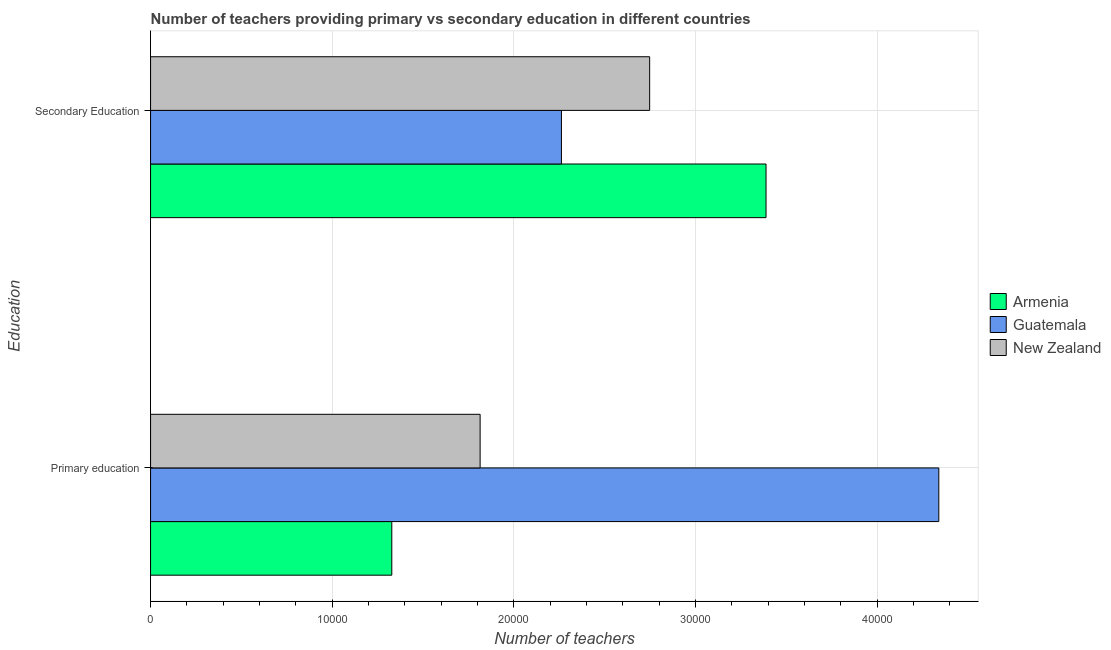How many different coloured bars are there?
Provide a succinct answer. 3. How many groups of bars are there?
Ensure brevity in your answer.  2. Are the number of bars per tick equal to the number of legend labels?
Your response must be concise. Yes. Are the number of bars on each tick of the Y-axis equal?
Provide a succinct answer. Yes. What is the number of secondary teachers in Guatemala?
Ensure brevity in your answer.  2.26e+04. Across all countries, what is the maximum number of secondary teachers?
Your answer should be very brief. 3.39e+04. Across all countries, what is the minimum number of primary teachers?
Offer a terse response. 1.33e+04. In which country was the number of secondary teachers maximum?
Offer a terse response. Armenia. In which country was the number of primary teachers minimum?
Offer a terse response. Armenia. What is the total number of secondary teachers in the graph?
Offer a very short reply. 8.40e+04. What is the difference between the number of primary teachers in New Zealand and that in Armenia?
Keep it short and to the point. 4863. What is the difference between the number of primary teachers in Armenia and the number of secondary teachers in New Zealand?
Your response must be concise. -1.42e+04. What is the average number of primary teachers per country?
Ensure brevity in your answer.  2.49e+04. What is the difference between the number of primary teachers and number of secondary teachers in Armenia?
Give a very brief answer. -2.06e+04. What is the ratio of the number of primary teachers in Guatemala to that in Armenia?
Offer a very short reply. 3.27. In how many countries, is the number of primary teachers greater than the average number of primary teachers taken over all countries?
Provide a succinct answer. 1. What does the 2nd bar from the top in Secondary Education represents?
Keep it short and to the point. Guatemala. What does the 2nd bar from the bottom in Secondary Education represents?
Make the answer very short. Guatemala. Are all the bars in the graph horizontal?
Make the answer very short. Yes. Are the values on the major ticks of X-axis written in scientific E-notation?
Ensure brevity in your answer.  No. Does the graph contain any zero values?
Offer a very short reply. No. Does the graph contain grids?
Your answer should be very brief. Yes. How are the legend labels stacked?
Your answer should be compact. Vertical. What is the title of the graph?
Offer a very short reply. Number of teachers providing primary vs secondary education in different countries. Does "Cayman Islands" appear as one of the legend labels in the graph?
Your answer should be very brief. No. What is the label or title of the X-axis?
Provide a succinct answer. Number of teachers. What is the label or title of the Y-axis?
Keep it short and to the point. Education. What is the Number of teachers in Armenia in Primary education?
Your response must be concise. 1.33e+04. What is the Number of teachers in Guatemala in Primary education?
Provide a short and direct response. 4.34e+04. What is the Number of teachers of New Zealand in Primary education?
Your answer should be compact. 1.81e+04. What is the Number of teachers of Armenia in Secondary Education?
Offer a terse response. 3.39e+04. What is the Number of teachers in Guatemala in Secondary Education?
Your answer should be compact. 2.26e+04. What is the Number of teachers in New Zealand in Secondary Education?
Your response must be concise. 2.75e+04. Across all Education, what is the maximum Number of teachers in Armenia?
Your response must be concise. 3.39e+04. Across all Education, what is the maximum Number of teachers in Guatemala?
Offer a very short reply. 4.34e+04. Across all Education, what is the maximum Number of teachers in New Zealand?
Make the answer very short. 2.75e+04. Across all Education, what is the minimum Number of teachers in Armenia?
Make the answer very short. 1.33e+04. Across all Education, what is the minimum Number of teachers in Guatemala?
Your response must be concise. 2.26e+04. Across all Education, what is the minimum Number of teachers of New Zealand?
Your answer should be compact. 1.81e+04. What is the total Number of teachers in Armenia in the graph?
Make the answer very short. 4.72e+04. What is the total Number of teachers in Guatemala in the graph?
Your response must be concise. 6.60e+04. What is the total Number of teachers of New Zealand in the graph?
Your answer should be very brief. 4.56e+04. What is the difference between the Number of teachers of Armenia in Primary education and that in Secondary Education?
Provide a short and direct response. -2.06e+04. What is the difference between the Number of teachers of Guatemala in Primary education and that in Secondary Education?
Provide a short and direct response. 2.08e+04. What is the difference between the Number of teachers in New Zealand in Primary education and that in Secondary Education?
Provide a succinct answer. -9335. What is the difference between the Number of teachers in Armenia in Primary education and the Number of teachers in Guatemala in Secondary Education?
Your answer should be compact. -9341. What is the difference between the Number of teachers in Armenia in Primary education and the Number of teachers in New Zealand in Secondary Education?
Provide a short and direct response. -1.42e+04. What is the difference between the Number of teachers of Guatemala in Primary education and the Number of teachers of New Zealand in Secondary Education?
Ensure brevity in your answer.  1.59e+04. What is the average Number of teachers of Armenia per Education?
Your response must be concise. 2.36e+04. What is the average Number of teachers in Guatemala per Education?
Give a very brief answer. 3.30e+04. What is the average Number of teachers of New Zealand per Education?
Offer a very short reply. 2.28e+04. What is the difference between the Number of teachers of Armenia and Number of teachers of Guatemala in Primary education?
Offer a terse response. -3.01e+04. What is the difference between the Number of teachers in Armenia and Number of teachers in New Zealand in Primary education?
Ensure brevity in your answer.  -4863. What is the difference between the Number of teachers of Guatemala and Number of teachers of New Zealand in Primary education?
Provide a succinct answer. 2.53e+04. What is the difference between the Number of teachers of Armenia and Number of teachers of Guatemala in Secondary Education?
Your answer should be compact. 1.13e+04. What is the difference between the Number of teachers of Armenia and Number of teachers of New Zealand in Secondary Education?
Offer a very short reply. 6408. What is the difference between the Number of teachers in Guatemala and Number of teachers in New Zealand in Secondary Education?
Give a very brief answer. -4857. What is the ratio of the Number of teachers in Armenia in Primary education to that in Secondary Education?
Your response must be concise. 0.39. What is the ratio of the Number of teachers in Guatemala in Primary education to that in Secondary Education?
Keep it short and to the point. 1.92. What is the ratio of the Number of teachers in New Zealand in Primary education to that in Secondary Education?
Your answer should be very brief. 0.66. What is the difference between the highest and the second highest Number of teachers of Armenia?
Your answer should be very brief. 2.06e+04. What is the difference between the highest and the second highest Number of teachers in Guatemala?
Provide a short and direct response. 2.08e+04. What is the difference between the highest and the second highest Number of teachers in New Zealand?
Keep it short and to the point. 9335. What is the difference between the highest and the lowest Number of teachers of Armenia?
Keep it short and to the point. 2.06e+04. What is the difference between the highest and the lowest Number of teachers of Guatemala?
Ensure brevity in your answer.  2.08e+04. What is the difference between the highest and the lowest Number of teachers in New Zealand?
Offer a terse response. 9335. 